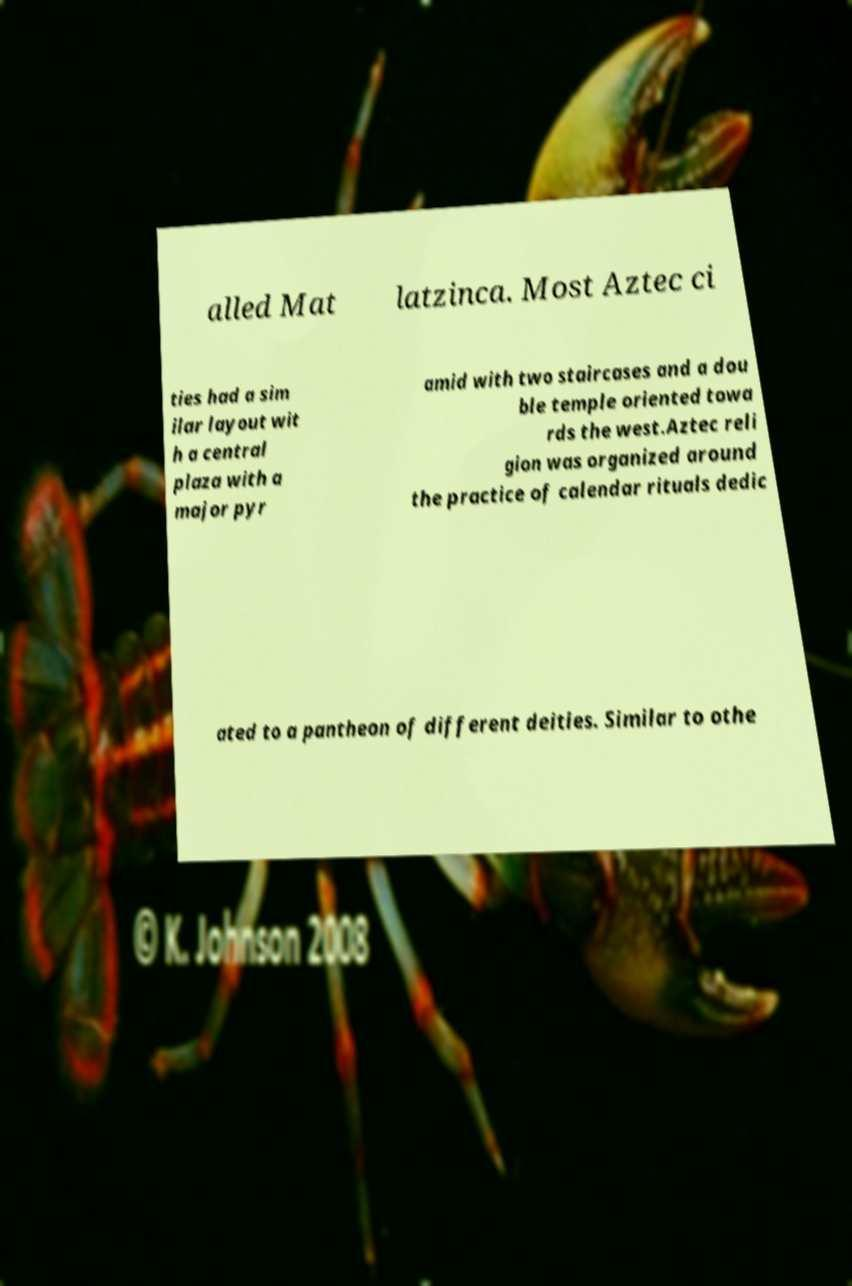Could you extract and type out the text from this image? alled Mat latzinca. Most Aztec ci ties had a sim ilar layout wit h a central plaza with a major pyr amid with two staircases and a dou ble temple oriented towa rds the west.Aztec reli gion was organized around the practice of calendar rituals dedic ated to a pantheon of different deities. Similar to othe 